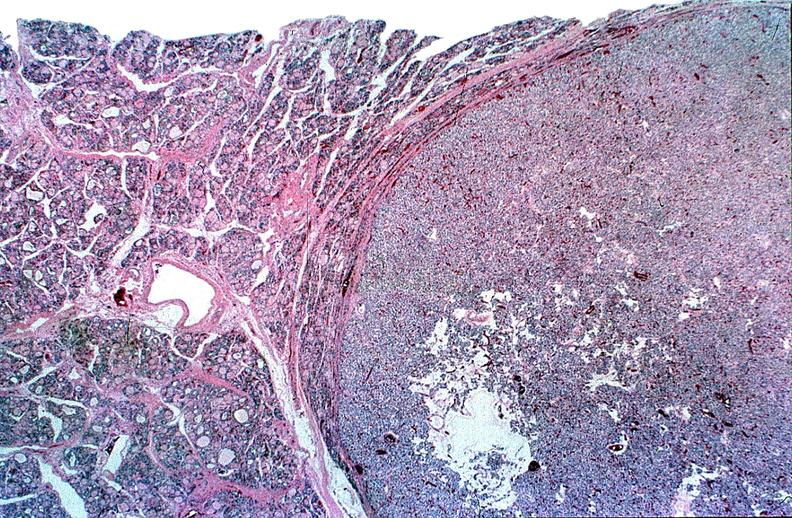where is this part in the figure?
Answer the question using a single word or phrase. Endocrine system 